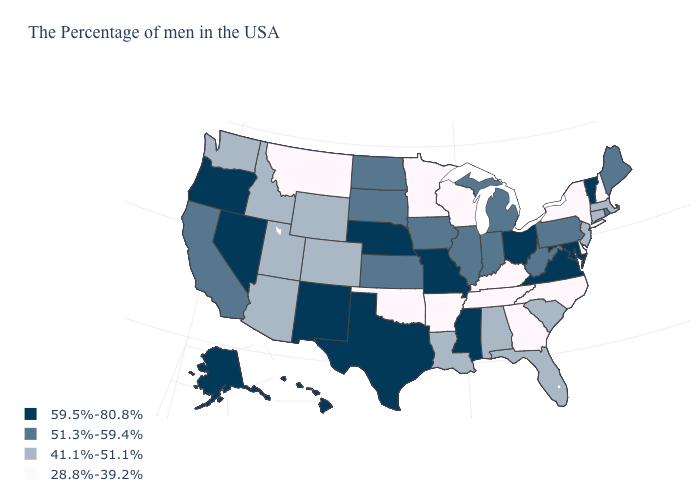Does the first symbol in the legend represent the smallest category?
Short answer required. No. Among the states that border Washington , does Oregon have the highest value?
Keep it brief. Yes. What is the value of Massachusetts?
Quick response, please. 41.1%-51.1%. What is the highest value in the West ?
Give a very brief answer. 59.5%-80.8%. Name the states that have a value in the range 28.8%-39.2%?
Concise answer only. New Hampshire, New York, Delaware, North Carolina, Georgia, Kentucky, Tennessee, Wisconsin, Arkansas, Minnesota, Oklahoma, Montana. Does Delaware have the lowest value in the USA?
Concise answer only. Yes. How many symbols are there in the legend?
Keep it brief. 4. What is the lowest value in the USA?
Keep it brief. 28.8%-39.2%. Among the states that border Connecticut , which have the lowest value?
Keep it brief. New York. What is the value of Florida?
Give a very brief answer. 41.1%-51.1%. Among the states that border Kentucky , which have the highest value?
Concise answer only. Virginia, Ohio, Missouri. Does Colorado have the lowest value in the West?
Quick response, please. No. Which states have the lowest value in the USA?
Quick response, please. New Hampshire, New York, Delaware, North Carolina, Georgia, Kentucky, Tennessee, Wisconsin, Arkansas, Minnesota, Oklahoma, Montana. What is the value of Kansas?
Concise answer only. 51.3%-59.4%. Name the states that have a value in the range 51.3%-59.4%?
Write a very short answer. Maine, Rhode Island, Pennsylvania, West Virginia, Michigan, Indiana, Illinois, Iowa, Kansas, South Dakota, North Dakota, California. 